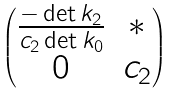<formula> <loc_0><loc_0><loc_500><loc_500>\begin{pmatrix} \frac { - \det { k _ { 2 } } } { c _ { 2 } \det { k _ { 0 } } } & * \\ 0 & c _ { 2 } \end{pmatrix}</formula> 